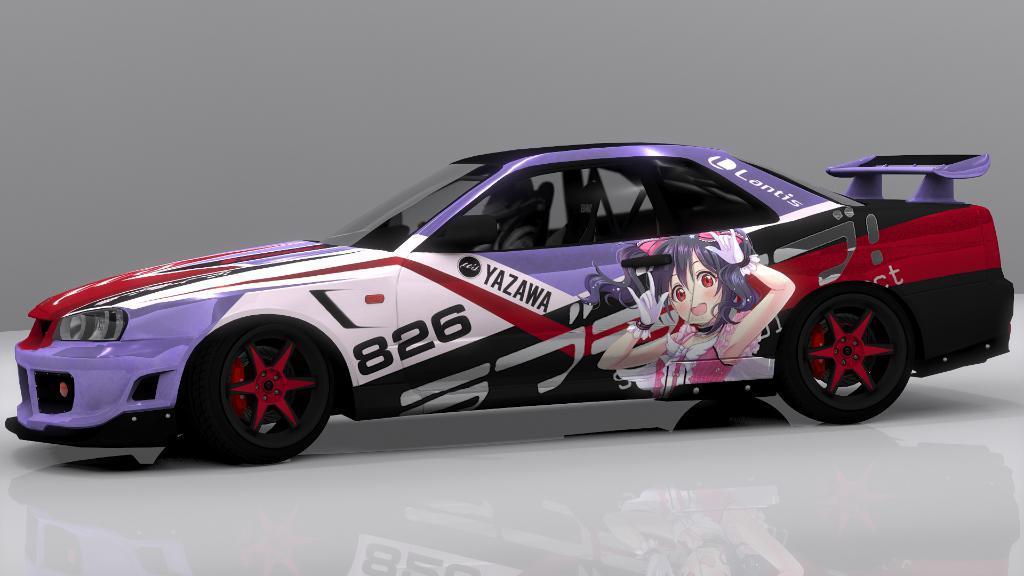How would you summarize this image in a sentence or two? In this image I can see a car and there is a white background. 